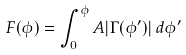Convert formula to latex. <formula><loc_0><loc_0><loc_500><loc_500>F ( \phi ) = \int _ { 0 } ^ { \phi } A | \Gamma ( \phi ^ { \prime } ) | \, d \phi ^ { \prime }</formula> 